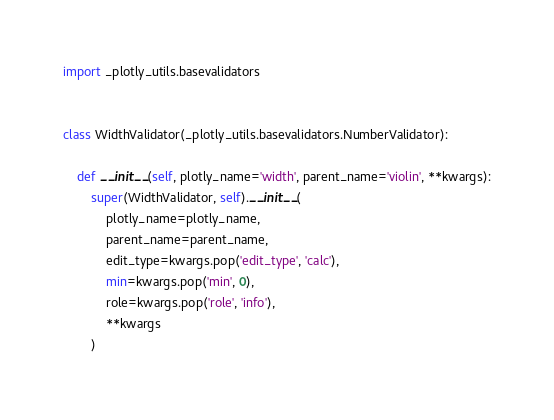Convert code to text. <code><loc_0><loc_0><loc_500><loc_500><_Python_>import _plotly_utils.basevalidators


class WidthValidator(_plotly_utils.basevalidators.NumberValidator):

    def __init__(self, plotly_name='width', parent_name='violin', **kwargs):
        super(WidthValidator, self).__init__(
            plotly_name=plotly_name,
            parent_name=parent_name,
            edit_type=kwargs.pop('edit_type', 'calc'),
            min=kwargs.pop('min', 0),
            role=kwargs.pop('role', 'info'),
            **kwargs
        )
</code> 